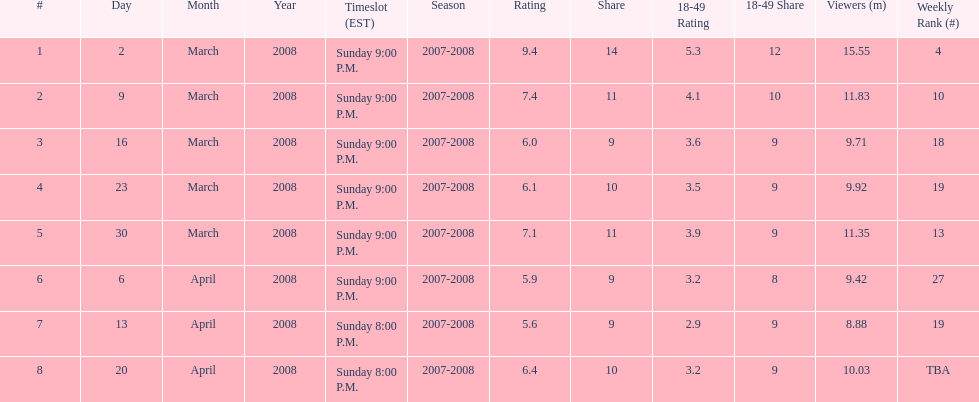How many shows had at least 10 million viewers? 4. 